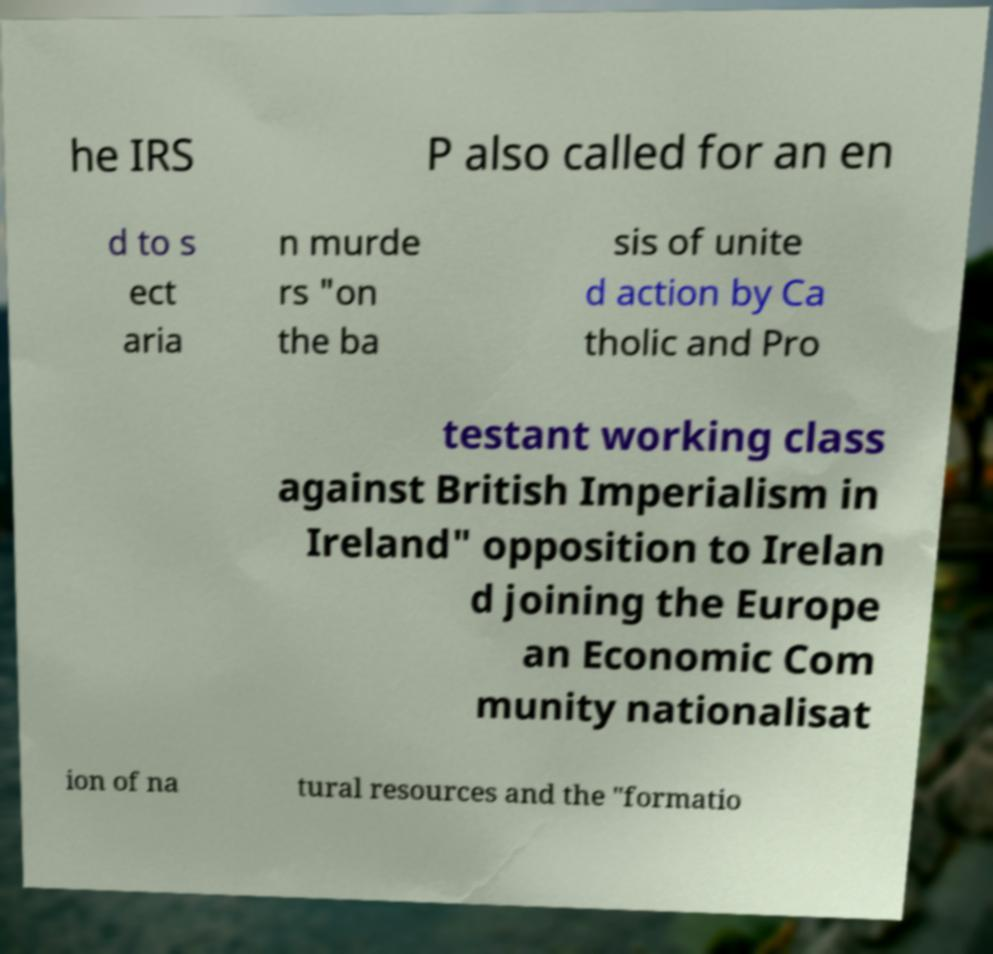Please read and relay the text visible in this image. What does it say? he IRS P also called for an en d to s ect aria n murde rs "on the ba sis of unite d action by Ca tholic and Pro testant working class against British Imperialism in Ireland" opposition to Irelan d joining the Europe an Economic Com munity nationalisat ion of na tural resources and the "formatio 